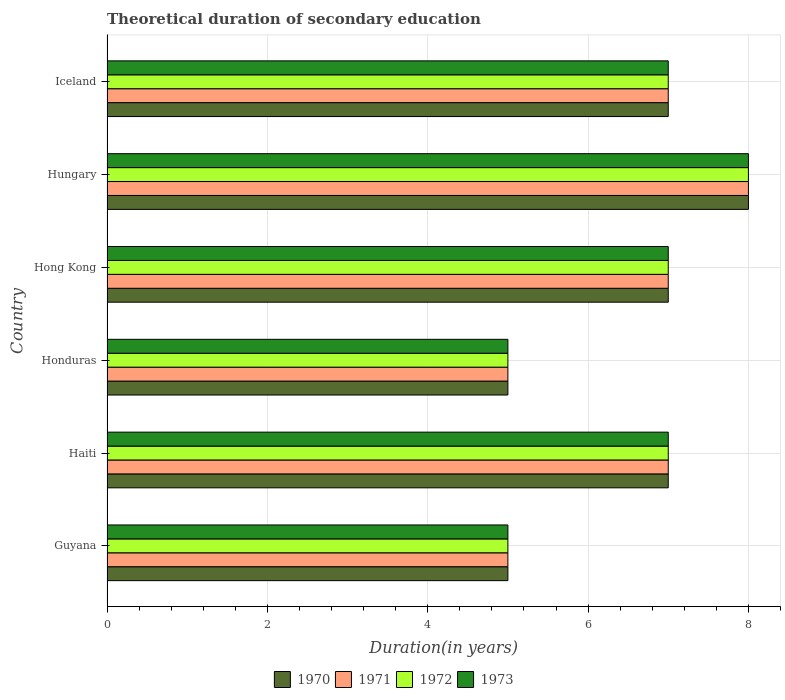How many groups of bars are there?
Make the answer very short. 6. How many bars are there on the 3rd tick from the bottom?
Keep it short and to the point. 4. What is the label of the 1st group of bars from the top?
Keep it short and to the point. Iceland. What is the total theoretical duration of secondary education in 1972 in Iceland?
Provide a short and direct response. 7. In which country was the total theoretical duration of secondary education in 1971 maximum?
Offer a terse response. Hungary. In which country was the total theoretical duration of secondary education in 1970 minimum?
Your answer should be very brief. Guyana. What is the difference between the total theoretical duration of secondary education in 1972 in Honduras and that in Hungary?
Ensure brevity in your answer.  -3. What is the average total theoretical duration of secondary education in 1970 per country?
Make the answer very short. 6.5. What is the difference between the total theoretical duration of secondary education in 1973 and total theoretical duration of secondary education in 1970 in Haiti?
Ensure brevity in your answer.  0. Is the total theoretical duration of secondary education in 1971 in Haiti less than that in Hungary?
Ensure brevity in your answer.  Yes. Is the difference between the total theoretical duration of secondary education in 1973 in Guyana and Haiti greater than the difference between the total theoretical duration of secondary education in 1970 in Guyana and Haiti?
Provide a succinct answer. No. What is the difference between the highest and the lowest total theoretical duration of secondary education in 1971?
Offer a very short reply. 3. In how many countries, is the total theoretical duration of secondary education in 1972 greater than the average total theoretical duration of secondary education in 1972 taken over all countries?
Give a very brief answer. 4. What does the 4th bar from the bottom in Hungary represents?
Ensure brevity in your answer.  1973. Is it the case that in every country, the sum of the total theoretical duration of secondary education in 1972 and total theoretical duration of secondary education in 1973 is greater than the total theoretical duration of secondary education in 1970?
Offer a very short reply. Yes. How many bars are there?
Provide a short and direct response. 24. How many countries are there in the graph?
Keep it short and to the point. 6. What is the difference between two consecutive major ticks on the X-axis?
Your answer should be very brief. 2. Does the graph contain grids?
Offer a terse response. Yes. Where does the legend appear in the graph?
Your response must be concise. Bottom center. How are the legend labels stacked?
Ensure brevity in your answer.  Horizontal. What is the title of the graph?
Offer a terse response. Theoretical duration of secondary education. Does "1970" appear as one of the legend labels in the graph?
Give a very brief answer. Yes. What is the label or title of the X-axis?
Provide a succinct answer. Duration(in years). What is the label or title of the Y-axis?
Make the answer very short. Country. What is the Duration(in years) in 1971 in Guyana?
Your response must be concise. 5. What is the Duration(in years) of 1972 in Guyana?
Provide a succinct answer. 5. What is the Duration(in years) of 1973 in Guyana?
Your answer should be compact. 5. What is the Duration(in years) in 1970 in Haiti?
Provide a succinct answer. 7. What is the Duration(in years) in 1971 in Honduras?
Provide a short and direct response. 5. What is the Duration(in years) in 1972 in Honduras?
Your response must be concise. 5. What is the Duration(in years) of 1973 in Honduras?
Give a very brief answer. 5. What is the Duration(in years) of 1970 in Hong Kong?
Offer a terse response. 7. What is the Duration(in years) in 1972 in Hong Kong?
Provide a succinct answer. 7. What is the Duration(in years) in 1970 in Hungary?
Keep it short and to the point. 8. What is the Duration(in years) in 1972 in Hungary?
Your answer should be compact. 8. What is the Duration(in years) of 1970 in Iceland?
Provide a short and direct response. 7. What is the Duration(in years) in 1972 in Iceland?
Make the answer very short. 7. What is the Duration(in years) of 1973 in Iceland?
Give a very brief answer. 7. Across all countries, what is the maximum Duration(in years) in 1970?
Ensure brevity in your answer.  8. What is the total Duration(in years) of 1970 in the graph?
Give a very brief answer. 39. What is the total Duration(in years) of 1972 in the graph?
Keep it short and to the point. 39. What is the total Duration(in years) in 1973 in the graph?
Your answer should be compact. 39. What is the difference between the Duration(in years) of 1970 in Guyana and that in Haiti?
Keep it short and to the point. -2. What is the difference between the Duration(in years) in 1971 in Guyana and that in Haiti?
Ensure brevity in your answer.  -2. What is the difference between the Duration(in years) in 1972 in Guyana and that in Haiti?
Offer a terse response. -2. What is the difference between the Duration(in years) of 1972 in Guyana and that in Honduras?
Provide a short and direct response. 0. What is the difference between the Duration(in years) of 1970 in Guyana and that in Hong Kong?
Give a very brief answer. -2. What is the difference between the Duration(in years) of 1970 in Guyana and that in Hungary?
Keep it short and to the point. -3. What is the difference between the Duration(in years) of 1971 in Guyana and that in Iceland?
Your answer should be compact. -2. What is the difference between the Duration(in years) of 1972 in Guyana and that in Iceland?
Make the answer very short. -2. What is the difference between the Duration(in years) of 1973 in Guyana and that in Iceland?
Offer a terse response. -2. What is the difference between the Duration(in years) of 1972 in Haiti and that in Honduras?
Keep it short and to the point. 2. What is the difference between the Duration(in years) in 1973 in Haiti and that in Honduras?
Your response must be concise. 2. What is the difference between the Duration(in years) of 1972 in Haiti and that in Hong Kong?
Keep it short and to the point. 0. What is the difference between the Duration(in years) in 1973 in Haiti and that in Hong Kong?
Offer a very short reply. 0. What is the difference between the Duration(in years) of 1972 in Haiti and that in Hungary?
Your answer should be very brief. -1. What is the difference between the Duration(in years) in 1973 in Haiti and that in Hungary?
Provide a short and direct response. -1. What is the difference between the Duration(in years) of 1970 in Haiti and that in Iceland?
Make the answer very short. 0. What is the difference between the Duration(in years) in 1971 in Haiti and that in Iceland?
Offer a terse response. 0. What is the difference between the Duration(in years) of 1970 in Honduras and that in Hong Kong?
Offer a terse response. -2. What is the difference between the Duration(in years) in 1972 in Honduras and that in Hong Kong?
Your answer should be compact. -2. What is the difference between the Duration(in years) in 1973 in Honduras and that in Hong Kong?
Give a very brief answer. -2. What is the difference between the Duration(in years) in 1970 in Honduras and that in Hungary?
Offer a terse response. -3. What is the difference between the Duration(in years) of 1971 in Honduras and that in Hungary?
Provide a succinct answer. -3. What is the difference between the Duration(in years) in 1972 in Honduras and that in Hungary?
Give a very brief answer. -3. What is the difference between the Duration(in years) in 1970 in Honduras and that in Iceland?
Provide a short and direct response. -2. What is the difference between the Duration(in years) of 1971 in Honduras and that in Iceland?
Provide a short and direct response. -2. What is the difference between the Duration(in years) in 1970 in Hong Kong and that in Hungary?
Ensure brevity in your answer.  -1. What is the difference between the Duration(in years) of 1971 in Hong Kong and that in Hungary?
Your answer should be compact. -1. What is the difference between the Duration(in years) of 1973 in Hong Kong and that in Hungary?
Ensure brevity in your answer.  -1. What is the difference between the Duration(in years) of 1970 in Hong Kong and that in Iceland?
Make the answer very short. 0. What is the difference between the Duration(in years) of 1971 in Hong Kong and that in Iceland?
Keep it short and to the point. 0. What is the difference between the Duration(in years) of 1970 in Hungary and that in Iceland?
Your answer should be compact. 1. What is the difference between the Duration(in years) in 1971 in Hungary and that in Iceland?
Ensure brevity in your answer.  1. What is the difference between the Duration(in years) in 1972 in Hungary and that in Iceland?
Make the answer very short. 1. What is the difference between the Duration(in years) in 1970 in Guyana and the Duration(in years) in 1971 in Honduras?
Ensure brevity in your answer.  0. What is the difference between the Duration(in years) in 1970 in Guyana and the Duration(in years) in 1973 in Honduras?
Provide a short and direct response. 0. What is the difference between the Duration(in years) in 1972 in Guyana and the Duration(in years) in 1973 in Honduras?
Give a very brief answer. 0. What is the difference between the Duration(in years) of 1970 in Guyana and the Duration(in years) of 1972 in Hong Kong?
Your answer should be very brief. -2. What is the difference between the Duration(in years) of 1970 in Guyana and the Duration(in years) of 1973 in Hong Kong?
Your answer should be compact. -2. What is the difference between the Duration(in years) in 1971 in Guyana and the Duration(in years) in 1972 in Hong Kong?
Your answer should be compact. -2. What is the difference between the Duration(in years) in 1970 in Guyana and the Duration(in years) in 1972 in Hungary?
Provide a succinct answer. -3. What is the difference between the Duration(in years) of 1971 in Guyana and the Duration(in years) of 1972 in Hungary?
Make the answer very short. -3. What is the difference between the Duration(in years) in 1971 in Guyana and the Duration(in years) in 1973 in Hungary?
Offer a very short reply. -3. What is the difference between the Duration(in years) in 1971 in Guyana and the Duration(in years) in 1973 in Iceland?
Ensure brevity in your answer.  -2. What is the difference between the Duration(in years) in 1972 in Guyana and the Duration(in years) in 1973 in Iceland?
Your answer should be compact. -2. What is the difference between the Duration(in years) in 1970 in Haiti and the Duration(in years) in 1971 in Honduras?
Provide a short and direct response. 2. What is the difference between the Duration(in years) in 1970 in Haiti and the Duration(in years) in 1972 in Honduras?
Your answer should be very brief. 2. What is the difference between the Duration(in years) of 1971 in Haiti and the Duration(in years) of 1973 in Honduras?
Ensure brevity in your answer.  2. What is the difference between the Duration(in years) in 1972 in Haiti and the Duration(in years) in 1973 in Honduras?
Your answer should be compact. 2. What is the difference between the Duration(in years) of 1970 in Haiti and the Duration(in years) of 1971 in Hong Kong?
Keep it short and to the point. 0. What is the difference between the Duration(in years) of 1970 in Haiti and the Duration(in years) of 1971 in Hungary?
Ensure brevity in your answer.  -1. What is the difference between the Duration(in years) in 1970 in Haiti and the Duration(in years) in 1972 in Hungary?
Give a very brief answer. -1. What is the difference between the Duration(in years) in 1971 in Haiti and the Duration(in years) in 1972 in Iceland?
Make the answer very short. 0. What is the difference between the Duration(in years) of 1971 in Haiti and the Duration(in years) of 1973 in Iceland?
Make the answer very short. 0. What is the difference between the Duration(in years) of 1972 in Haiti and the Duration(in years) of 1973 in Iceland?
Your answer should be compact. 0. What is the difference between the Duration(in years) in 1970 in Honduras and the Duration(in years) in 1971 in Hong Kong?
Your answer should be very brief. -2. What is the difference between the Duration(in years) in 1970 in Honduras and the Duration(in years) in 1972 in Hungary?
Offer a very short reply. -3. What is the difference between the Duration(in years) in 1971 in Honduras and the Duration(in years) in 1972 in Hungary?
Your answer should be compact. -3. What is the difference between the Duration(in years) of 1971 in Honduras and the Duration(in years) of 1973 in Hungary?
Your answer should be compact. -3. What is the difference between the Duration(in years) of 1972 in Honduras and the Duration(in years) of 1973 in Hungary?
Give a very brief answer. -3. What is the difference between the Duration(in years) in 1970 in Honduras and the Duration(in years) in 1972 in Iceland?
Ensure brevity in your answer.  -2. What is the difference between the Duration(in years) of 1970 in Honduras and the Duration(in years) of 1973 in Iceland?
Your answer should be compact. -2. What is the difference between the Duration(in years) of 1971 in Honduras and the Duration(in years) of 1972 in Iceland?
Offer a terse response. -2. What is the difference between the Duration(in years) in 1972 in Honduras and the Duration(in years) in 1973 in Iceland?
Ensure brevity in your answer.  -2. What is the difference between the Duration(in years) of 1970 in Hong Kong and the Duration(in years) of 1971 in Hungary?
Provide a short and direct response. -1. What is the difference between the Duration(in years) of 1970 in Hong Kong and the Duration(in years) of 1972 in Hungary?
Give a very brief answer. -1. What is the difference between the Duration(in years) of 1970 in Hong Kong and the Duration(in years) of 1973 in Hungary?
Keep it short and to the point. -1. What is the difference between the Duration(in years) in 1971 in Hong Kong and the Duration(in years) in 1972 in Hungary?
Keep it short and to the point. -1. What is the difference between the Duration(in years) of 1971 in Hong Kong and the Duration(in years) of 1973 in Hungary?
Your answer should be very brief. -1. What is the difference between the Duration(in years) of 1971 in Hong Kong and the Duration(in years) of 1972 in Iceland?
Give a very brief answer. 0. What is the difference between the Duration(in years) of 1970 in Hungary and the Duration(in years) of 1972 in Iceland?
Provide a short and direct response. 1. What is the difference between the Duration(in years) in 1972 in Hungary and the Duration(in years) in 1973 in Iceland?
Keep it short and to the point. 1. What is the average Duration(in years) of 1971 per country?
Your answer should be compact. 6.5. What is the average Duration(in years) in 1972 per country?
Offer a very short reply. 6.5. What is the average Duration(in years) of 1973 per country?
Ensure brevity in your answer.  6.5. What is the difference between the Duration(in years) in 1970 and Duration(in years) in 1972 in Guyana?
Provide a short and direct response. 0. What is the difference between the Duration(in years) of 1971 and Duration(in years) of 1972 in Guyana?
Your answer should be very brief. 0. What is the difference between the Duration(in years) in 1970 and Duration(in years) in 1972 in Haiti?
Your answer should be compact. 0. What is the difference between the Duration(in years) of 1970 and Duration(in years) of 1973 in Haiti?
Provide a succinct answer. 0. What is the difference between the Duration(in years) in 1971 and Duration(in years) in 1972 in Haiti?
Your answer should be compact. 0. What is the difference between the Duration(in years) in 1971 and Duration(in years) in 1973 in Haiti?
Provide a short and direct response. 0. What is the difference between the Duration(in years) of 1972 and Duration(in years) of 1973 in Haiti?
Ensure brevity in your answer.  0. What is the difference between the Duration(in years) of 1970 and Duration(in years) of 1971 in Honduras?
Make the answer very short. 0. What is the difference between the Duration(in years) of 1970 and Duration(in years) of 1972 in Honduras?
Ensure brevity in your answer.  0. What is the difference between the Duration(in years) in 1970 and Duration(in years) in 1973 in Honduras?
Keep it short and to the point. 0. What is the difference between the Duration(in years) of 1971 and Duration(in years) of 1972 in Honduras?
Keep it short and to the point. 0. What is the difference between the Duration(in years) in 1971 and Duration(in years) in 1973 in Honduras?
Keep it short and to the point. 0. What is the difference between the Duration(in years) of 1970 and Duration(in years) of 1971 in Hong Kong?
Offer a terse response. 0. What is the difference between the Duration(in years) in 1970 and Duration(in years) in 1973 in Hong Kong?
Your response must be concise. 0. What is the difference between the Duration(in years) of 1971 and Duration(in years) of 1972 in Hong Kong?
Your answer should be very brief. 0. What is the difference between the Duration(in years) in 1971 and Duration(in years) in 1973 in Hungary?
Your response must be concise. 0. What is the difference between the Duration(in years) of 1972 and Duration(in years) of 1973 in Hungary?
Your answer should be very brief. 0. What is the difference between the Duration(in years) of 1970 and Duration(in years) of 1971 in Iceland?
Your response must be concise. 0. What is the difference between the Duration(in years) of 1971 and Duration(in years) of 1972 in Iceland?
Your answer should be compact. 0. What is the ratio of the Duration(in years) of 1970 in Guyana to that in Haiti?
Offer a very short reply. 0.71. What is the ratio of the Duration(in years) in 1973 in Guyana to that in Haiti?
Offer a terse response. 0.71. What is the ratio of the Duration(in years) in 1971 in Guyana to that in Honduras?
Make the answer very short. 1. What is the ratio of the Duration(in years) in 1971 in Guyana to that in Hong Kong?
Provide a short and direct response. 0.71. What is the ratio of the Duration(in years) in 1972 in Guyana to that in Hong Kong?
Provide a succinct answer. 0.71. What is the ratio of the Duration(in years) of 1973 in Guyana to that in Hong Kong?
Provide a succinct answer. 0.71. What is the ratio of the Duration(in years) in 1970 in Guyana to that in Hungary?
Provide a short and direct response. 0.62. What is the ratio of the Duration(in years) in 1972 in Haiti to that in Honduras?
Provide a short and direct response. 1.4. What is the ratio of the Duration(in years) in 1973 in Haiti to that in Honduras?
Provide a succinct answer. 1.4. What is the ratio of the Duration(in years) of 1970 in Haiti to that in Hong Kong?
Your answer should be very brief. 1. What is the ratio of the Duration(in years) in 1970 in Haiti to that in Hungary?
Provide a short and direct response. 0.88. What is the ratio of the Duration(in years) in 1971 in Haiti to that in Hungary?
Your answer should be compact. 0.88. What is the ratio of the Duration(in years) of 1971 in Haiti to that in Iceland?
Your response must be concise. 1. What is the ratio of the Duration(in years) in 1970 in Honduras to that in Hong Kong?
Offer a very short reply. 0.71. What is the ratio of the Duration(in years) of 1972 in Honduras to that in Hungary?
Offer a very short reply. 0.62. What is the ratio of the Duration(in years) in 1973 in Honduras to that in Hungary?
Your response must be concise. 0.62. What is the ratio of the Duration(in years) in 1972 in Honduras to that in Iceland?
Provide a succinct answer. 0.71. What is the ratio of the Duration(in years) of 1973 in Honduras to that in Iceland?
Give a very brief answer. 0.71. What is the ratio of the Duration(in years) in 1970 in Hong Kong to that in Hungary?
Offer a very short reply. 0.88. What is the ratio of the Duration(in years) in 1972 in Hong Kong to that in Hungary?
Offer a terse response. 0.88. What is the ratio of the Duration(in years) of 1973 in Hong Kong to that in Hungary?
Offer a very short reply. 0.88. What is the ratio of the Duration(in years) of 1970 in Hong Kong to that in Iceland?
Your response must be concise. 1. What is the ratio of the Duration(in years) of 1971 in Hong Kong to that in Iceland?
Your answer should be compact. 1. What is the ratio of the Duration(in years) in 1972 in Hong Kong to that in Iceland?
Your answer should be compact. 1. What is the ratio of the Duration(in years) in 1973 in Hong Kong to that in Iceland?
Offer a terse response. 1. What is the ratio of the Duration(in years) in 1973 in Hungary to that in Iceland?
Keep it short and to the point. 1.14. What is the difference between the highest and the second highest Duration(in years) in 1970?
Offer a very short reply. 1. What is the difference between the highest and the second highest Duration(in years) of 1972?
Make the answer very short. 1. What is the difference between the highest and the lowest Duration(in years) of 1970?
Offer a terse response. 3. What is the difference between the highest and the lowest Duration(in years) of 1971?
Your answer should be compact. 3. 